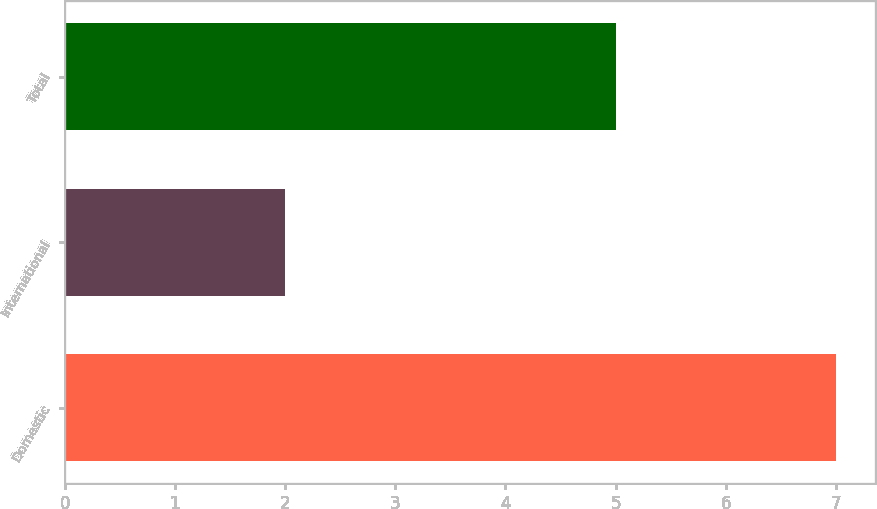Convert chart. <chart><loc_0><loc_0><loc_500><loc_500><bar_chart><fcel>Domestic<fcel>International<fcel>Total<nl><fcel>7<fcel>2<fcel>5<nl></chart> 